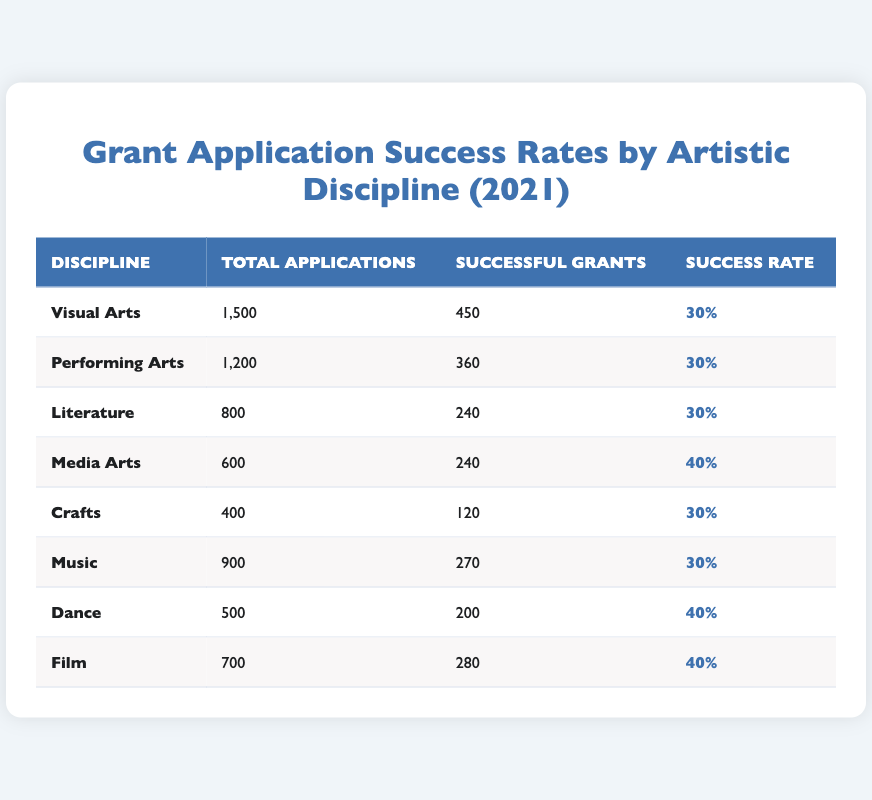What is the success rate for Visual Arts? The success rate for Visual Arts is stated directly in the table under the "Success Rate" column for that discipline. It is 30%.
Answer: 30% How many successful grants were given in the Music discipline? The number of successful grants for Music can be found in the "Successful Grants" column specific to that discipline. It is 270.
Answer: 270 Is the success rate for Crafts higher than 30%? The success rate for Crafts is presented in the "Success Rate" column, and it is 30%. Therefore, it is not higher than 30%.
Answer: No Which discipline has the highest success rate, and what is that rate? The disciplines with the highest success rates can be compared in the "Success Rate" column. Media Arts, Dance, and Film each have a success rate of 40%, which is the highest.
Answer: Media Arts, Dance, and Film; 40% What is the total number of applications submitted across all disciplines? To find the total number of applications, add the "Total Applications" from each discipline: 1500 (Visual Arts) + 1200 (Performing Arts) + 800 (Literature) + 600 (Media Arts) + 400 (Crafts) + 900 (Music) + 500 (Dance) + 700 (Film) = 5100.
Answer: 5100 How many more successful grants were given in Media Arts compared to Crafts? To answer this, subtract the number of successful grants in Crafts (120) from those in Media Arts (240): 240 - 120 = 120.
Answer: 120 What percentage of the total applications did Dance achieve in successful grants? First, find the number of successful grants for Dance, which is 200. Then, divide 200 by the total applications in Dance (500), resulting in 200/500 = 0.4. To convert to a percentage, multiply by 100: 0.4 * 100 = 40%.
Answer: 40% Are the success rates for the Performing Arts and Music the same? By checking the "Success Rate" column for both Performing Arts and Music, we see both are listed as 30%. Therefore, they have the same success rate.
Answer: Yes 